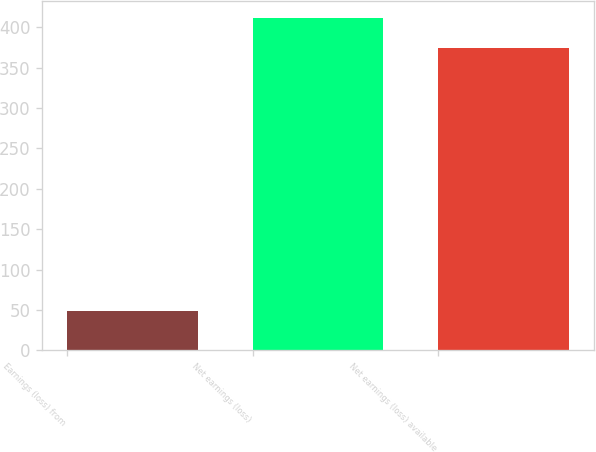<chart> <loc_0><loc_0><loc_500><loc_500><bar_chart><fcel>Earnings (loss) from<fcel>Net earnings (loss)<fcel>Net earnings (loss) available<nl><fcel>49<fcel>411.7<fcel>374<nl></chart> 